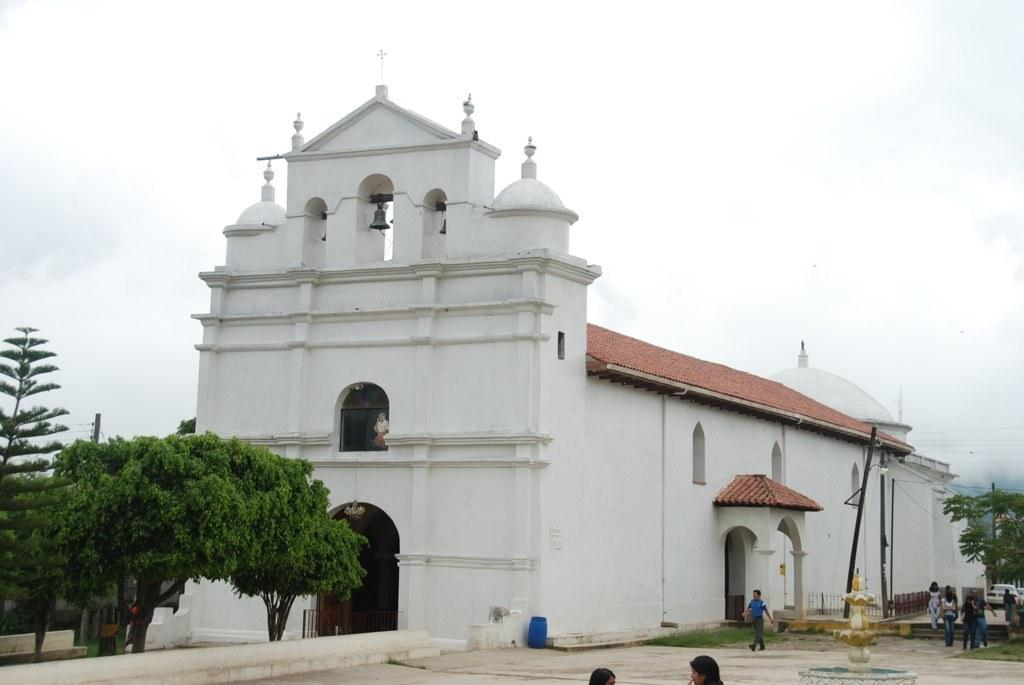What is the color of the building in the image? The building in the image is white. What type of natural elements can be seen in the image? There are trees in the image. What man-made objects are present in the image? There are poles in the image. Who or what is visible in the image? There are people in the image. What can be seen above the buildings and trees in the image? The sky is visible in the image. What type of quiver is being used by the secretary in the image? There is no secretary or quiver present in the image. What suggestion is being made by the people in the image? The image does not depict any suggestions being made by the people; it only shows their presence. 